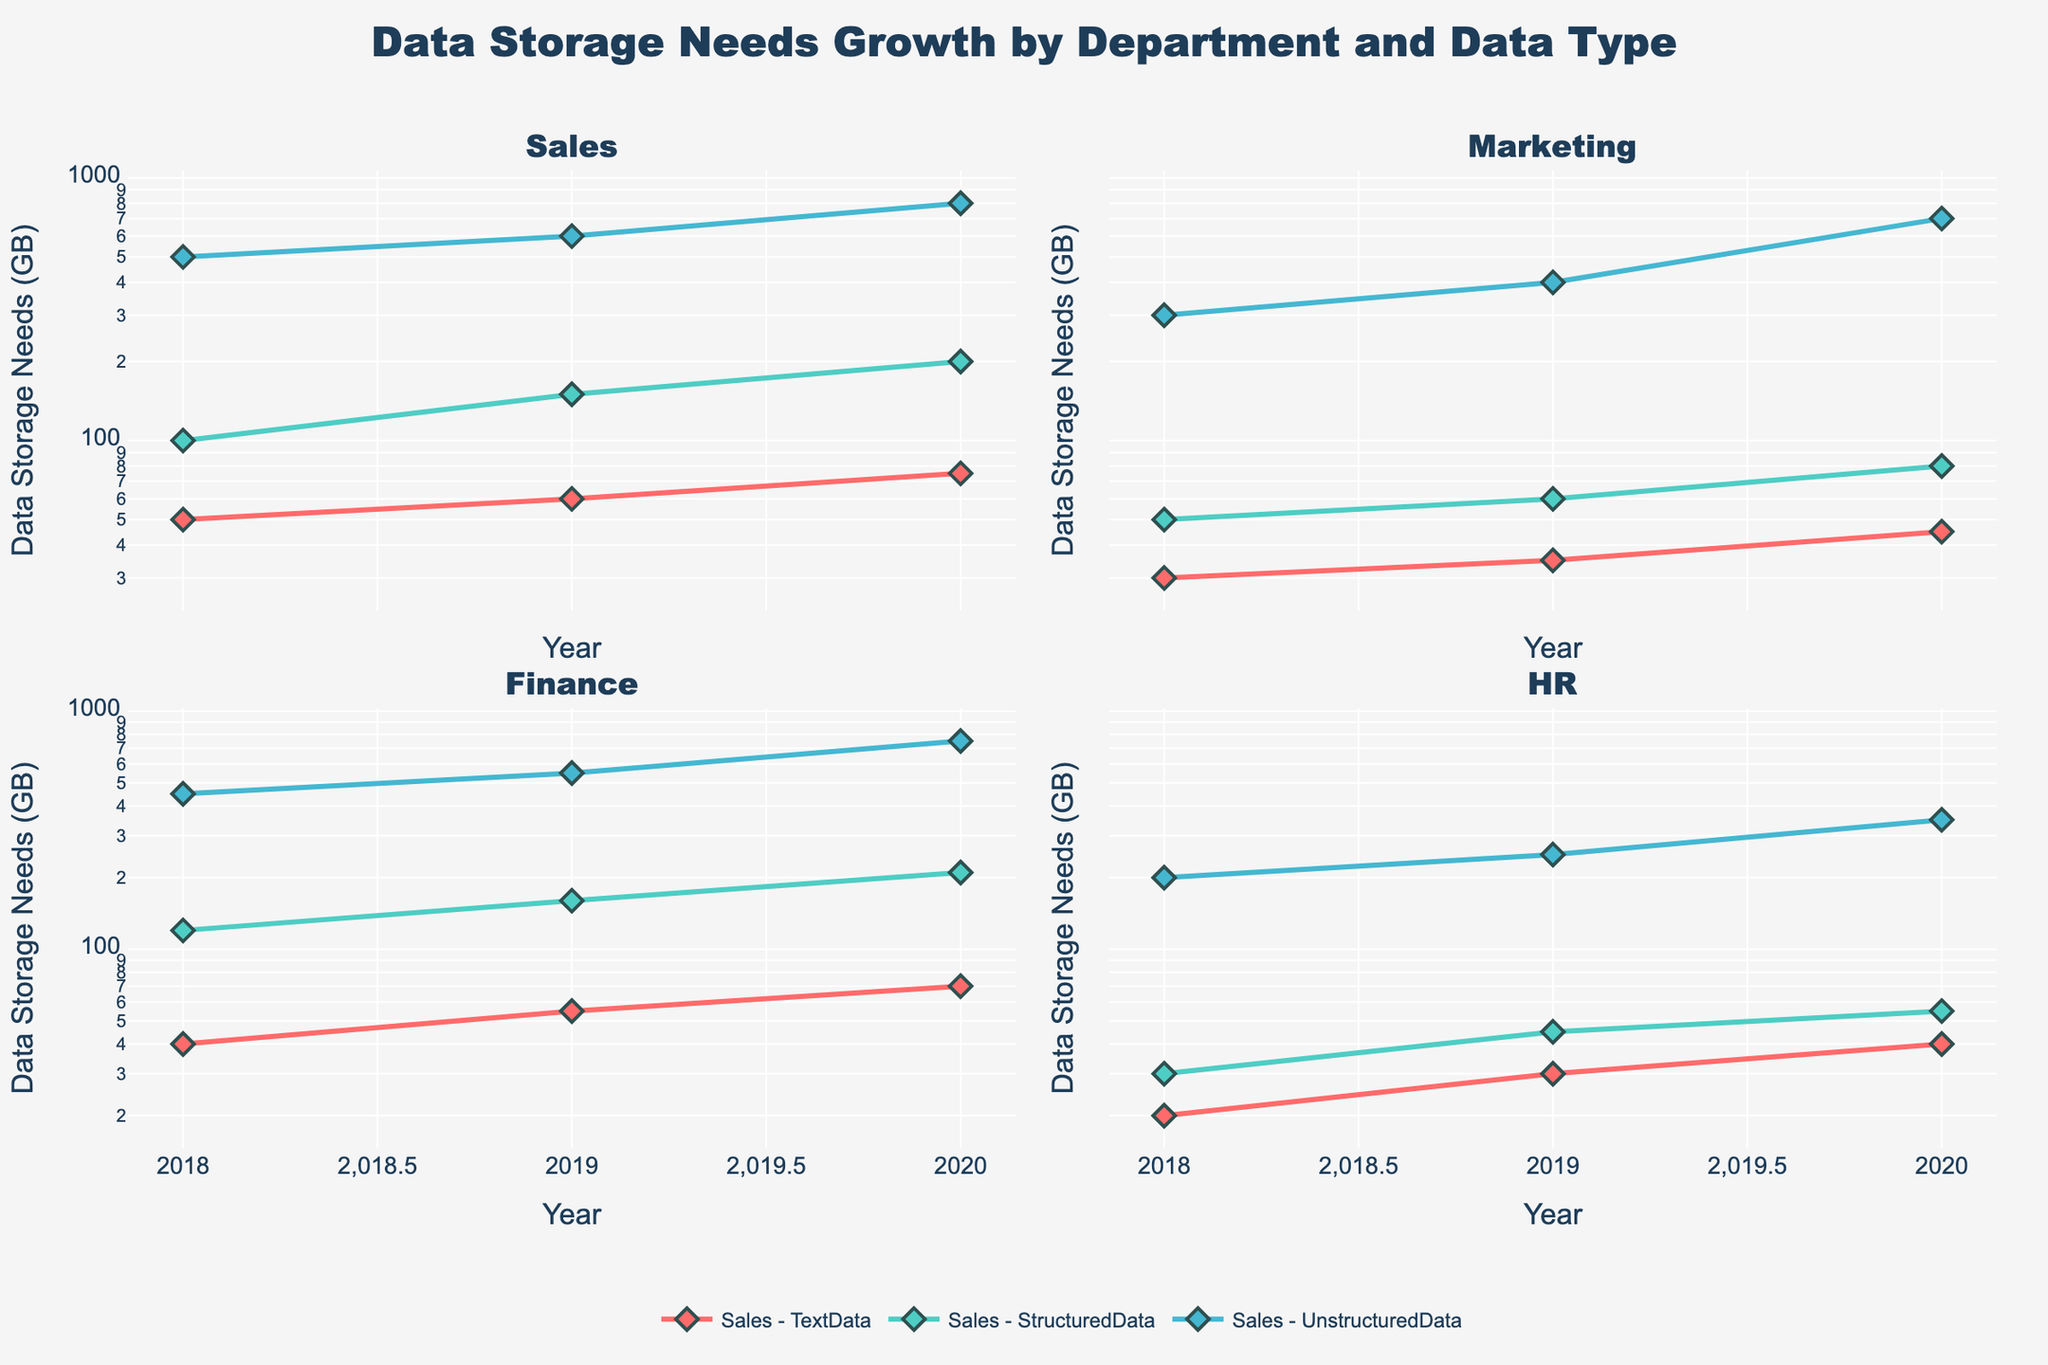What's the title of the plot? The title of the plot is found at the top center. It reads "Data Storage Needs Growth by Department and Data Type".
Answer: Data Storage Needs Growth by Department and Data Type How many departments are represented in the plot? The plot has four subplots, one for each department. These departments are labeled as Sales, Marketing, Finance, and HR.
Answer: 4 Which data type shows the largest increase in storage needs for the Sales department from 2018 to 2020? By observing the Sales department subplot, the line representing Unstructured Data shows the largest increase in storage needs, moving from 500 GB in 2018 to 800 GB in 2020.
Answer: Unstructured Data What is the overall trend in data storage needs for Text Data across all departments from 2018 to 2020? Across all department subplots, the lines representing Text Data show an increasing trend from 2018 to 2020.
Answer: Increasing Compare the 2020 data storage needs for Structured Data in Marketing and HR. Which one is higher? By looking at the points for Structured Data in 2020 in both the Marketing and HR subplots, Marketing has 80 GB, while HR has 55 GB.
Answer: Marketing Which data type in the Marketing department had greater storage needs in 2019 compared to 2018, and by how much did it increase? In the Marketing subplot, all data types increased in storage needs from 2018 to 2019. Unstructured Data increased from 300 GB in 2018 to 400 GB in 2019, showing an increase of 100 GB.
Answer: Unstructured Data, 100 GB What is the color used to represent Text Data in the plots? The color corresponding to Text Data lines across all subplots is a red hue.
Answer: Red Which department has the highest data storage needs for Unstructured Data in 2019? Referencing the subplots and considering the 2019 values, Sales has 600 GB, Marketing has 400 GB, Finance has 550 GB, and HR has 250 GB. The highest among these is the Sales department.
Answer: Sales What is the log-scale range for the y-axis in all subplots? By observing the y-axes of the subplots, the log-scale range appears to span from 10^1 (10 GB) to 10^3 (1000 GB).
Answer: 10 GB to 1000 GB How does the growth of Structured Data in the Finance department compare from 2018 to 2020? The subplot for Finance reveals that Structured Data increased from 120 GB in 2018 to 210 GB in 2020, indicating a significant growth over these years.
Answer: Increased significantly 